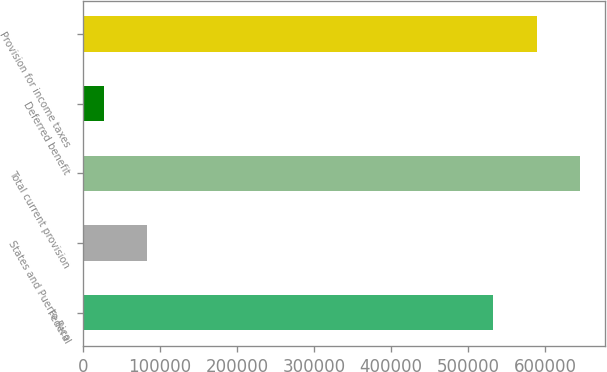Convert chart. <chart><loc_0><loc_0><loc_500><loc_500><bar_chart><fcel>Federal<fcel>States and Puerto Rico<fcel>Total current provision<fcel>Deferred benefit<fcel>Provision for income taxes<nl><fcel>532722<fcel>83000.5<fcel>645139<fcel>26792<fcel>588930<nl></chart> 